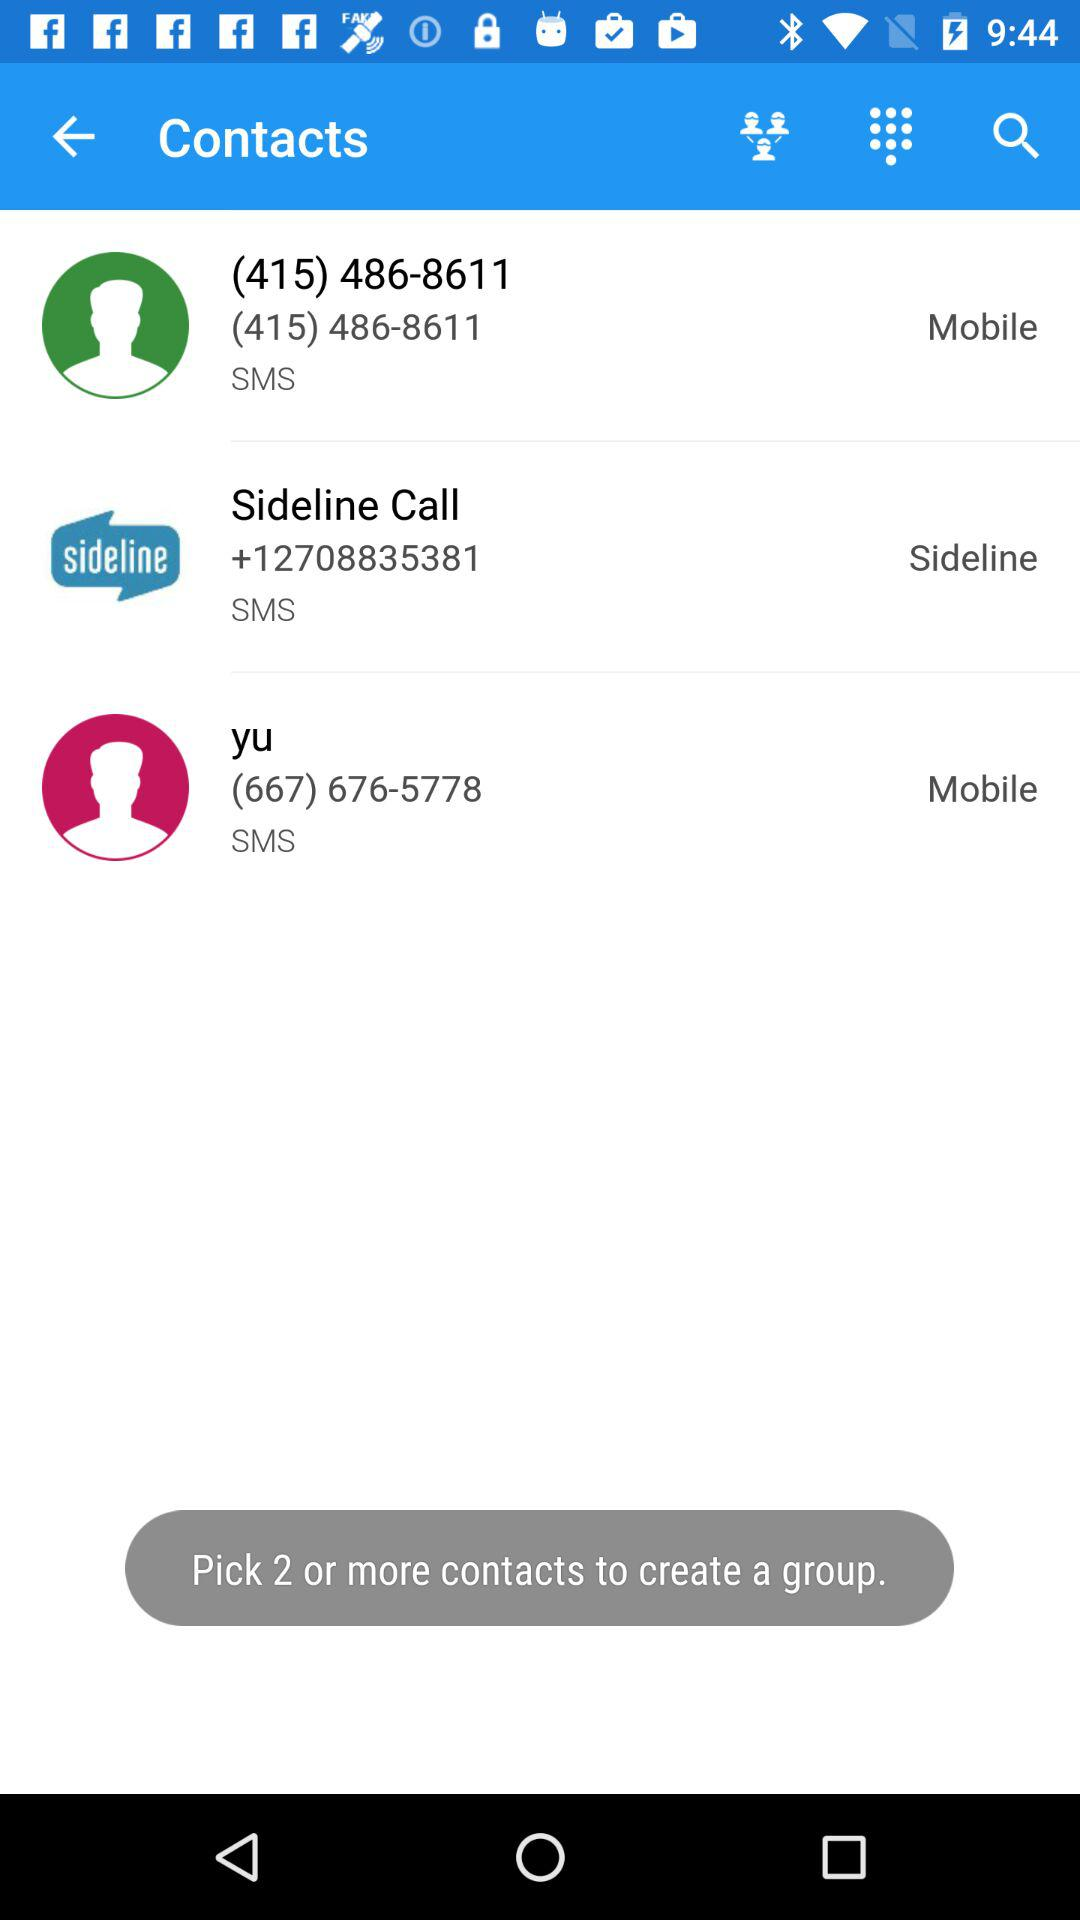How many contacts have a phone number?
Answer the question using a single word or phrase. 3 